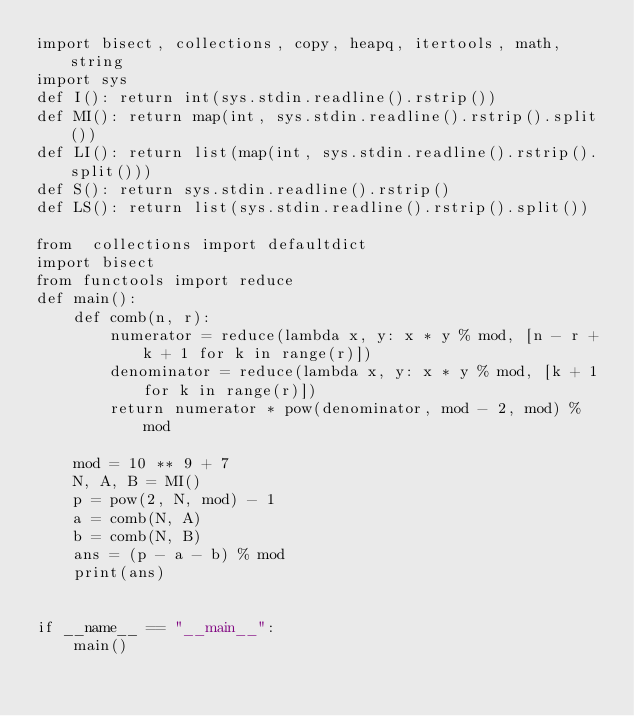<code> <loc_0><loc_0><loc_500><loc_500><_Python_>import bisect, collections, copy, heapq, itertools, math, string
import sys
def I(): return int(sys.stdin.readline().rstrip())
def MI(): return map(int, sys.stdin.readline().rstrip().split())
def LI(): return list(map(int, sys.stdin.readline().rstrip().split()))
def S(): return sys.stdin.readline().rstrip()
def LS(): return list(sys.stdin.readline().rstrip().split())

from  collections import defaultdict
import bisect
from functools import reduce
def main():
    def comb(n, r):
        numerator = reduce(lambda x, y: x * y % mod, [n - r + k + 1 for k in range(r)])
        denominator = reduce(lambda x, y: x * y % mod, [k + 1 for k in range(r)])
        return numerator * pow(denominator, mod - 2, mod) % mod

    mod = 10 ** 9 + 7
    N, A, B = MI()
    p = pow(2, N, mod) - 1
    a = comb(N, A)
    b = comb(N, B)
    ans = (p - a - b) % mod
    print(ans)


if __name__ == "__main__":
    main()
</code> 